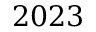Convert formula to latex. <formula><loc_0><loc_0><loc_500><loc_500>2 0 2 3</formula> 